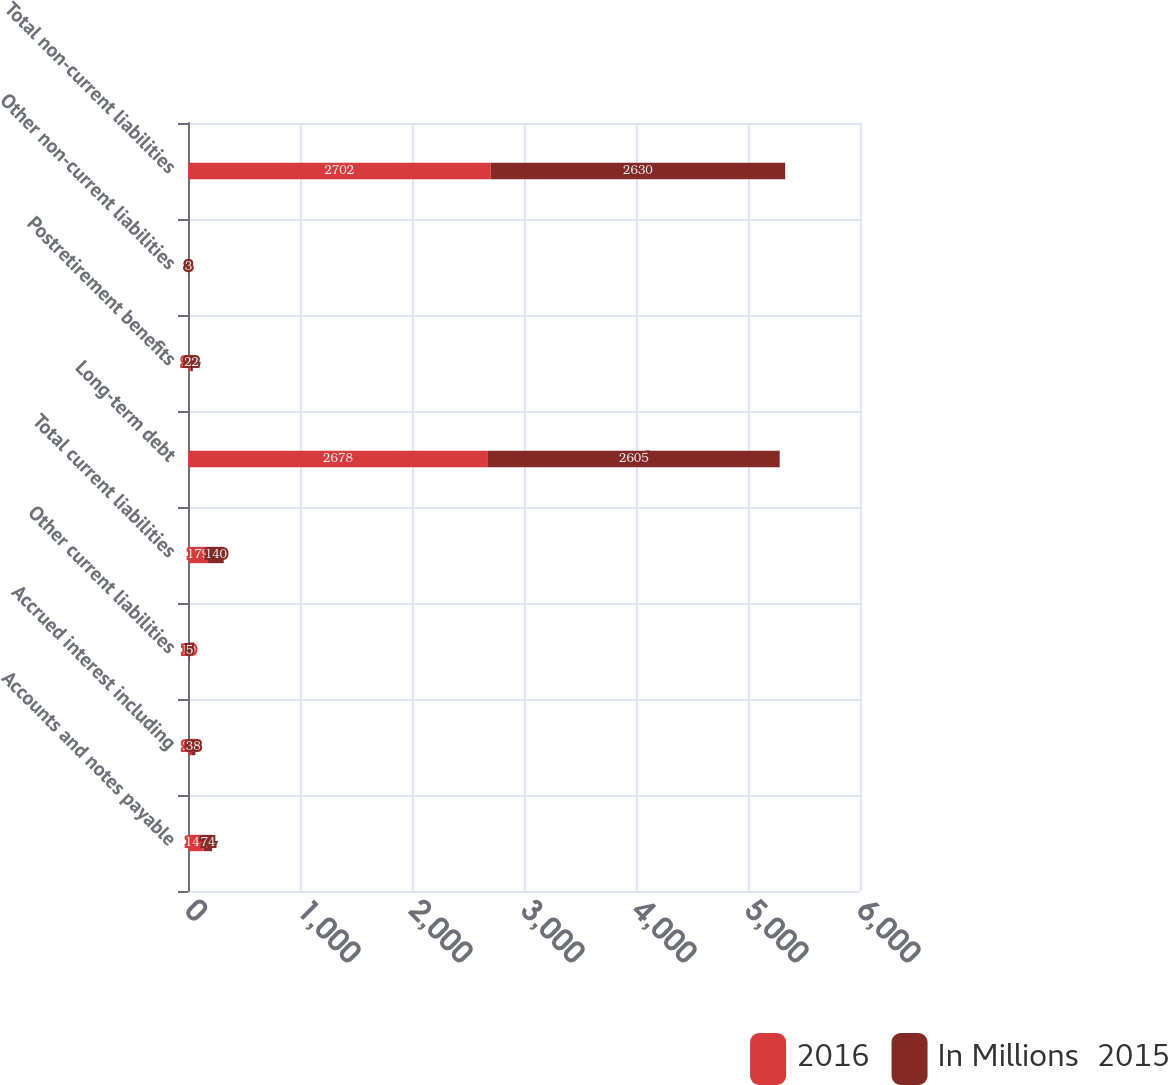Convert chart to OTSL. <chart><loc_0><loc_0><loc_500><loc_500><stacked_bar_chart><ecel><fcel>Accounts and notes payable<fcel>Accrued interest including<fcel>Other current liabilities<fcel>Total current liabilities<fcel>Long-term debt<fcel>Postretirement benefits<fcel>Other non-current liabilities<fcel>Total non-current liabilities<nl><fcel>2016<fcel>141<fcel>28<fcel>10<fcel>179<fcel>2678<fcel>21<fcel>3<fcel>2702<nl><fcel>In Millions  2015<fcel>74<fcel>38<fcel>5<fcel>140<fcel>2605<fcel>22<fcel>3<fcel>2630<nl></chart> 